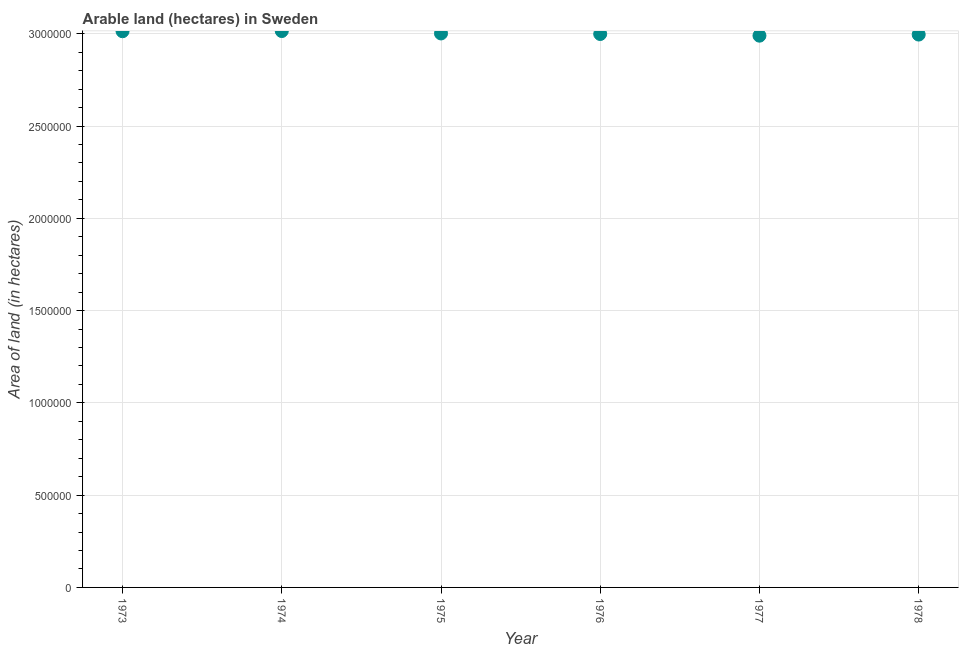What is the area of land in 1973?
Provide a succinct answer. 3.01e+06. Across all years, what is the maximum area of land?
Your answer should be very brief. 3.02e+06. Across all years, what is the minimum area of land?
Give a very brief answer. 2.99e+06. In which year was the area of land maximum?
Provide a short and direct response. 1974. What is the sum of the area of land?
Your answer should be very brief. 1.80e+07. What is the difference between the area of land in 1975 and 1976?
Provide a short and direct response. 3000. What is the average area of land per year?
Your response must be concise. 3.00e+06. What is the median area of land?
Your response must be concise. 3.00e+06. Do a majority of the years between 1978 and 1977 (inclusive) have area of land greater than 1600000 hectares?
Provide a short and direct response. No. What is the ratio of the area of land in 1973 to that in 1976?
Your response must be concise. 1.01. Is the area of land in 1973 less than that in 1974?
Offer a very short reply. Yes. What is the difference between the highest and the lowest area of land?
Give a very brief answer. 2.50e+04. In how many years, is the area of land greater than the average area of land taken over all years?
Give a very brief answer. 2. How many dotlines are there?
Offer a very short reply. 1. Are the values on the major ticks of Y-axis written in scientific E-notation?
Your response must be concise. No. Does the graph contain any zero values?
Provide a short and direct response. No. What is the title of the graph?
Provide a short and direct response. Arable land (hectares) in Sweden. What is the label or title of the X-axis?
Keep it short and to the point. Year. What is the label or title of the Y-axis?
Offer a very short reply. Area of land (in hectares). What is the Area of land (in hectares) in 1973?
Give a very brief answer. 3.01e+06. What is the Area of land (in hectares) in 1974?
Your answer should be very brief. 3.02e+06. What is the Area of land (in hectares) in 1975?
Offer a very short reply. 3.00e+06. What is the Area of land (in hectares) in 1976?
Your answer should be compact. 3.00e+06. What is the Area of land (in hectares) in 1977?
Offer a terse response. 2.99e+06. What is the Area of land (in hectares) in 1978?
Your response must be concise. 3.00e+06. What is the difference between the Area of land (in hectares) in 1973 and 1974?
Give a very brief answer. -1000. What is the difference between the Area of land (in hectares) in 1973 and 1975?
Give a very brief answer. 1.20e+04. What is the difference between the Area of land (in hectares) in 1973 and 1976?
Make the answer very short. 1.50e+04. What is the difference between the Area of land (in hectares) in 1973 and 1977?
Ensure brevity in your answer.  2.40e+04. What is the difference between the Area of land (in hectares) in 1973 and 1978?
Keep it short and to the point. 1.80e+04. What is the difference between the Area of land (in hectares) in 1974 and 1975?
Give a very brief answer. 1.30e+04. What is the difference between the Area of land (in hectares) in 1974 and 1976?
Offer a terse response. 1.60e+04. What is the difference between the Area of land (in hectares) in 1974 and 1977?
Ensure brevity in your answer.  2.50e+04. What is the difference between the Area of land (in hectares) in 1974 and 1978?
Give a very brief answer. 1.90e+04. What is the difference between the Area of land (in hectares) in 1975 and 1976?
Provide a short and direct response. 3000. What is the difference between the Area of land (in hectares) in 1975 and 1977?
Ensure brevity in your answer.  1.20e+04. What is the difference between the Area of land (in hectares) in 1975 and 1978?
Keep it short and to the point. 6000. What is the difference between the Area of land (in hectares) in 1976 and 1977?
Keep it short and to the point. 9000. What is the difference between the Area of land (in hectares) in 1976 and 1978?
Make the answer very short. 3000. What is the difference between the Area of land (in hectares) in 1977 and 1978?
Your answer should be compact. -6000. What is the ratio of the Area of land (in hectares) in 1974 to that in 1977?
Your response must be concise. 1.01. What is the ratio of the Area of land (in hectares) in 1974 to that in 1978?
Your answer should be very brief. 1.01. What is the ratio of the Area of land (in hectares) in 1975 to that in 1976?
Ensure brevity in your answer.  1. What is the ratio of the Area of land (in hectares) in 1975 to that in 1977?
Your response must be concise. 1. 